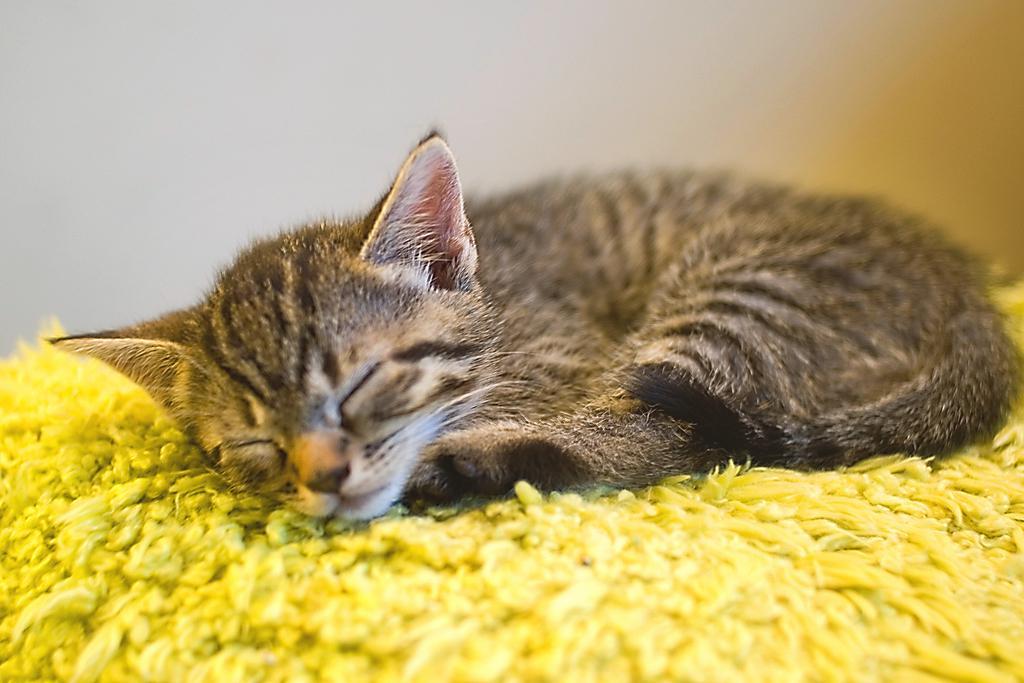Could you give a brief overview of what you see in this image? In the center of the image we can see a cat lying on the mat. In the background there is a wall. 